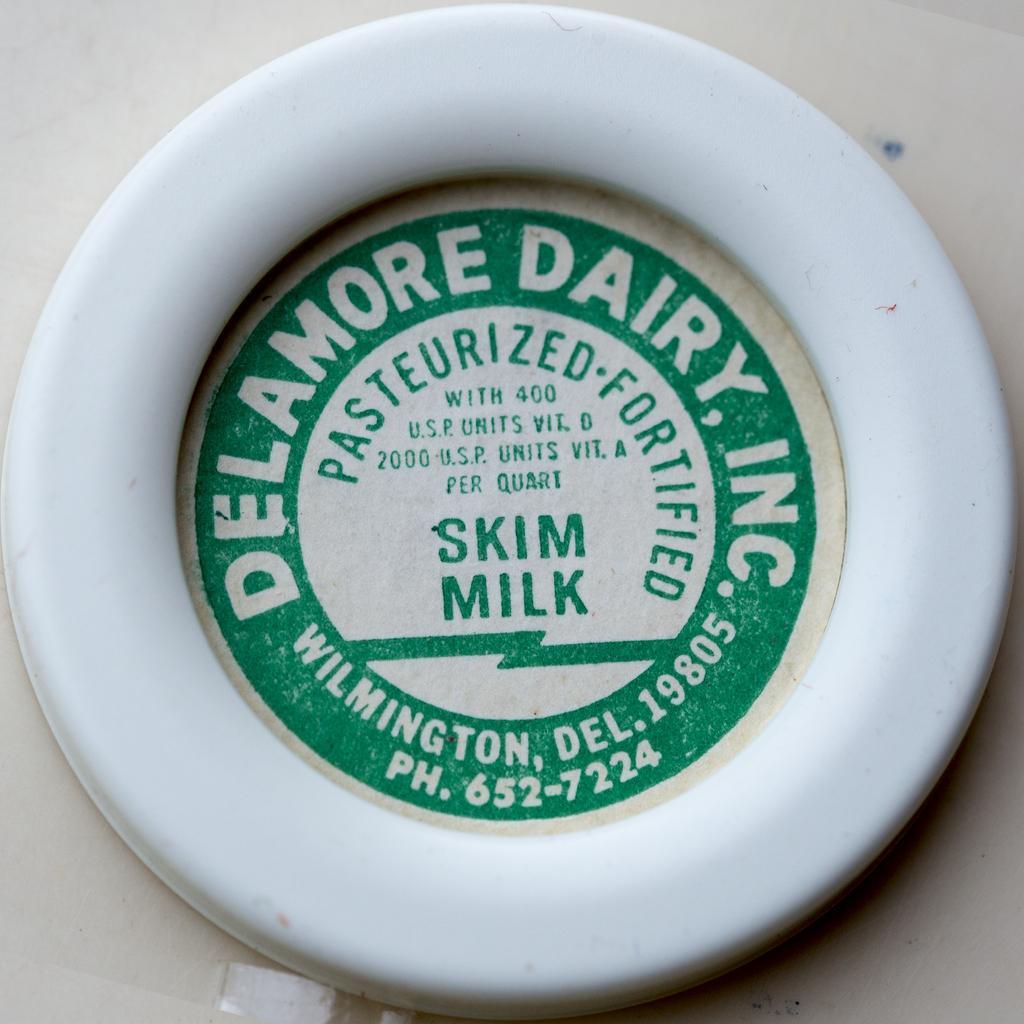Describe this image in one or two sentences. There is an object in the center of the image and text on it. 